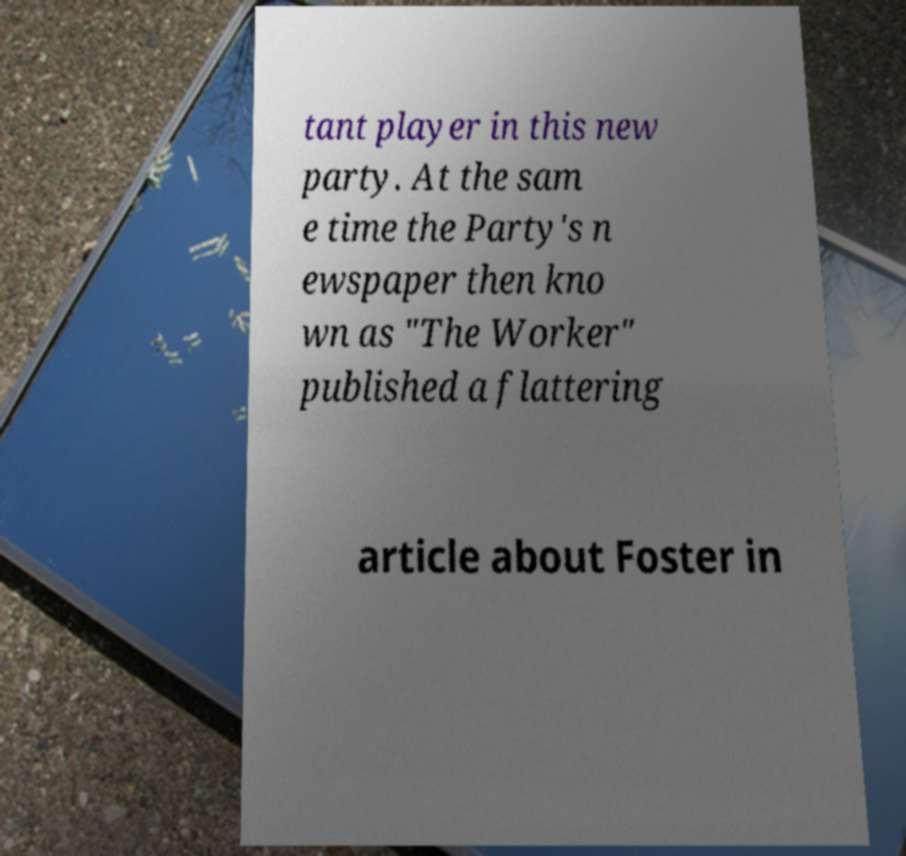Please read and relay the text visible in this image. What does it say? tant player in this new party. At the sam e time the Party's n ewspaper then kno wn as "The Worker" published a flattering article about Foster in 